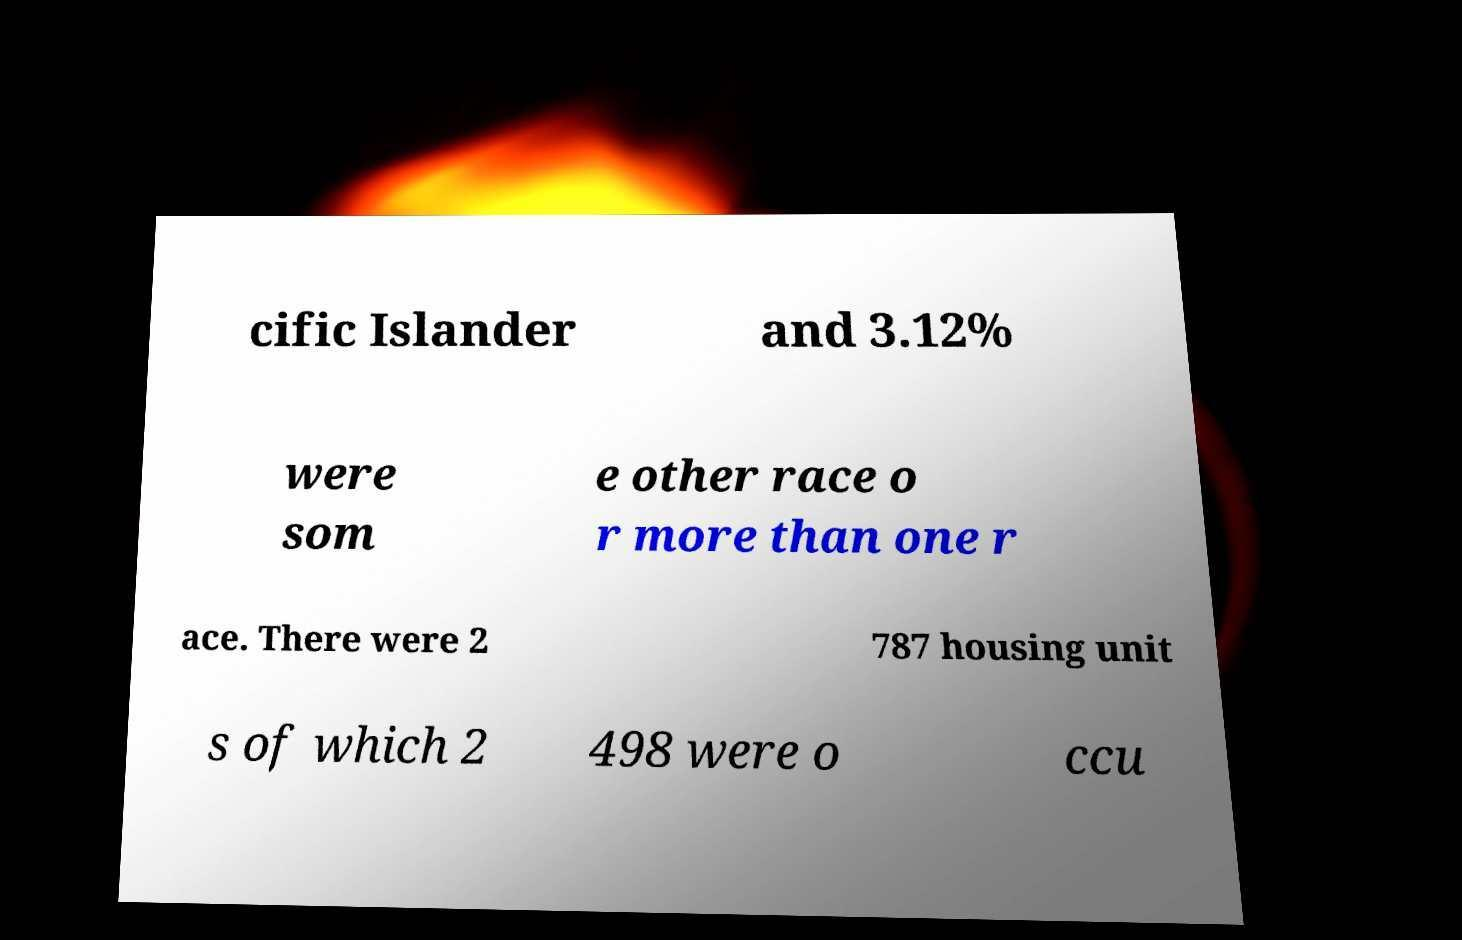Could you extract and type out the text from this image? cific Islander and 3.12% were som e other race o r more than one r ace. There were 2 787 housing unit s of which 2 498 were o ccu 